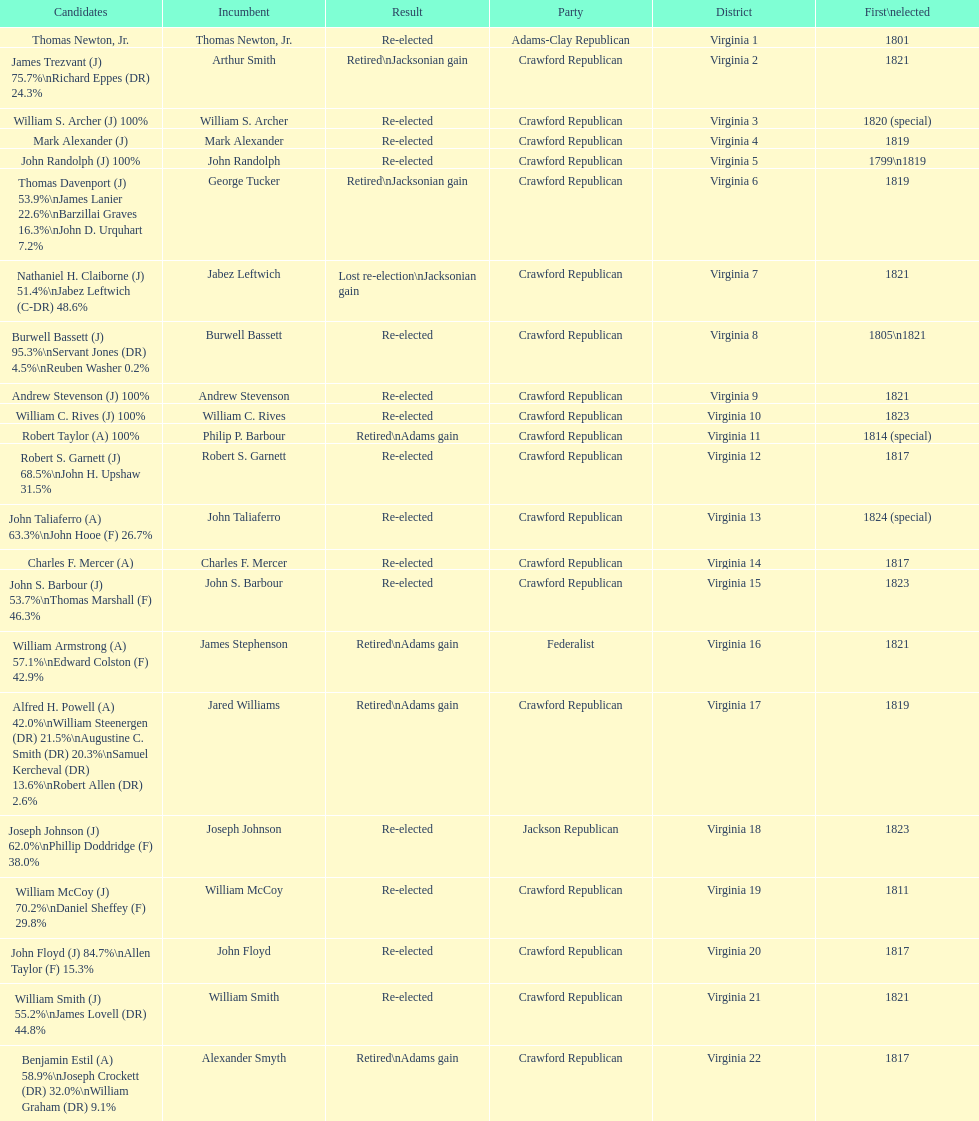Number of incumbents who retired or lost re-election 7. 